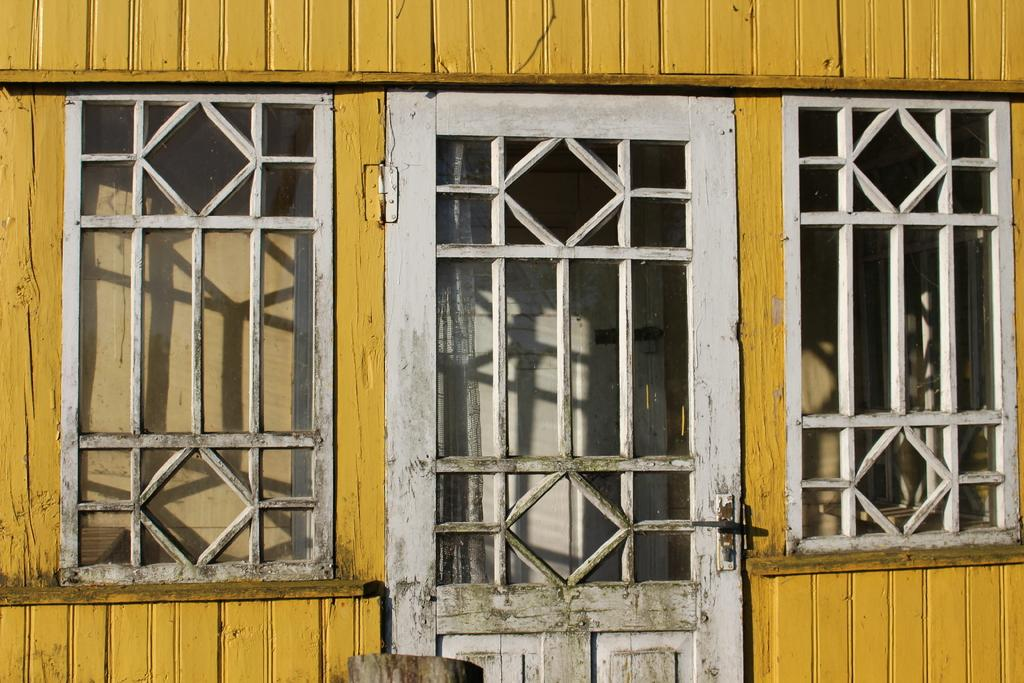What type of door is visible in the image? There is a wooden door in the image. What other wooden features can be seen in the image? There are wooden windows in the image. What type of structure might the wooden door and windows belong to? The wooden door and windows suggest that the image depicts a house. Can you see any mint plants growing near the wooden door in the image? There is no mention of mint plants in the image, so we cannot determine if any are present. Is there a giraffe visible in the image? No, there is no giraffe present in the image. 